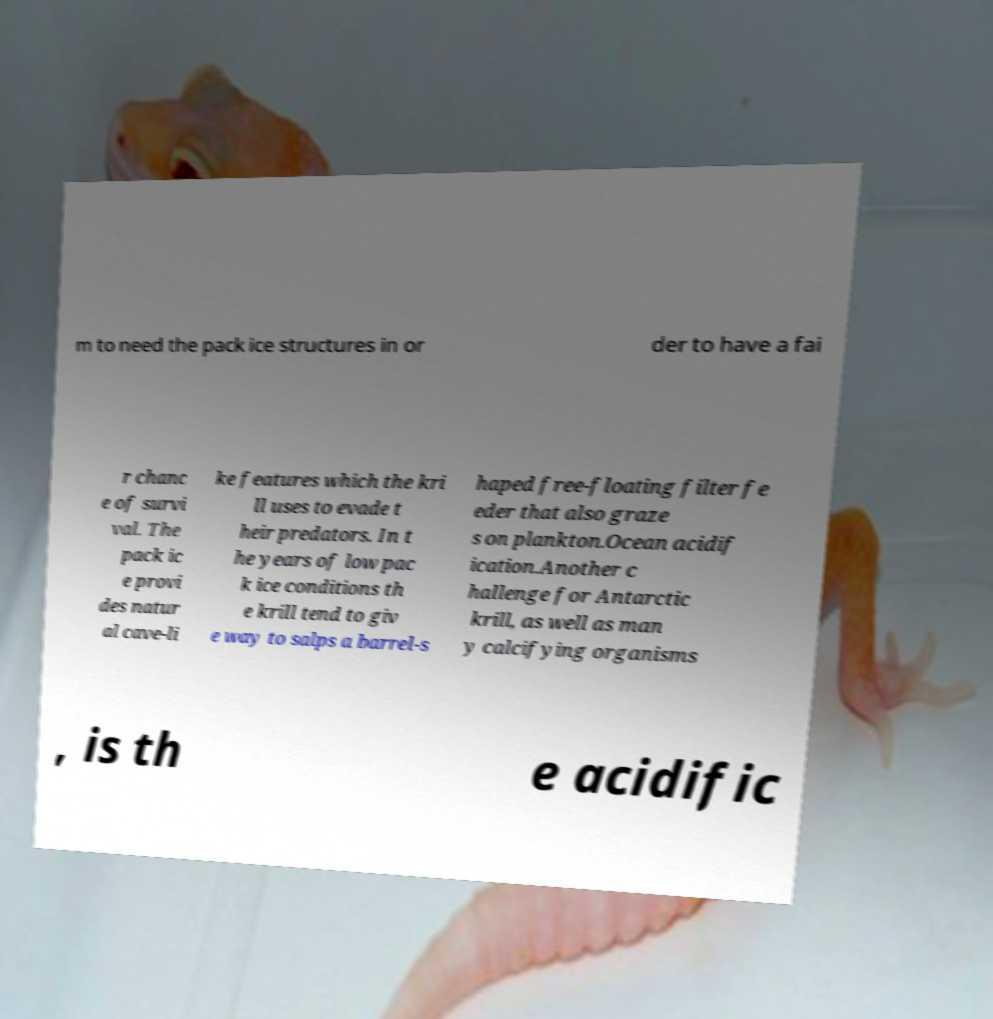For documentation purposes, I need the text within this image transcribed. Could you provide that? m to need the pack ice structures in or der to have a fai r chanc e of survi val. The pack ic e provi des natur al cave-li ke features which the kri ll uses to evade t heir predators. In t he years of low pac k ice conditions th e krill tend to giv e way to salps a barrel-s haped free-floating filter fe eder that also graze s on plankton.Ocean acidif ication.Another c hallenge for Antarctic krill, as well as man y calcifying organisms , is th e acidific 